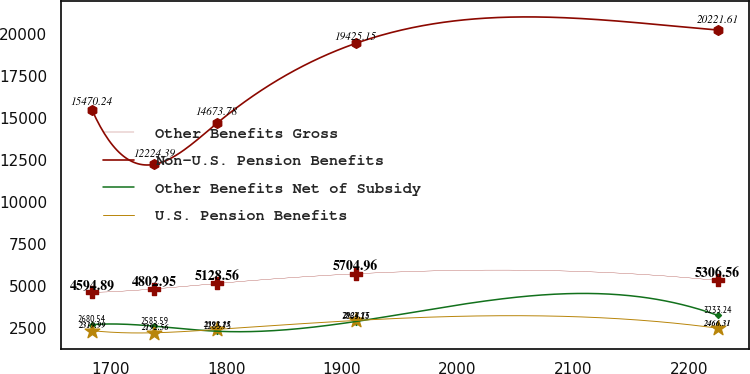Convert chart. <chart><loc_0><loc_0><loc_500><loc_500><line_chart><ecel><fcel>Other Benefits Gross<fcel>Non-U.S. Pension Benefits<fcel>Other Benefits Net of Subsidy<fcel>U.S. Pension Benefits<nl><fcel>1684.05<fcel>4594.89<fcel>15470.2<fcel>2680.54<fcel>2319.99<nl><fcel>1738.11<fcel>4802.95<fcel>12224.4<fcel>2585.59<fcel>2192.56<nl><fcel>1792.17<fcel>5128.56<fcel>14673.8<fcel>2283.75<fcel>2393.15<nl><fcel>1911.95<fcel>5704.96<fcel>19425.2<fcel>2863.13<fcel>2924.15<nl><fcel>2224.63<fcel>5306.56<fcel>20221.6<fcel>3233.24<fcel>2466.31<nl></chart> 